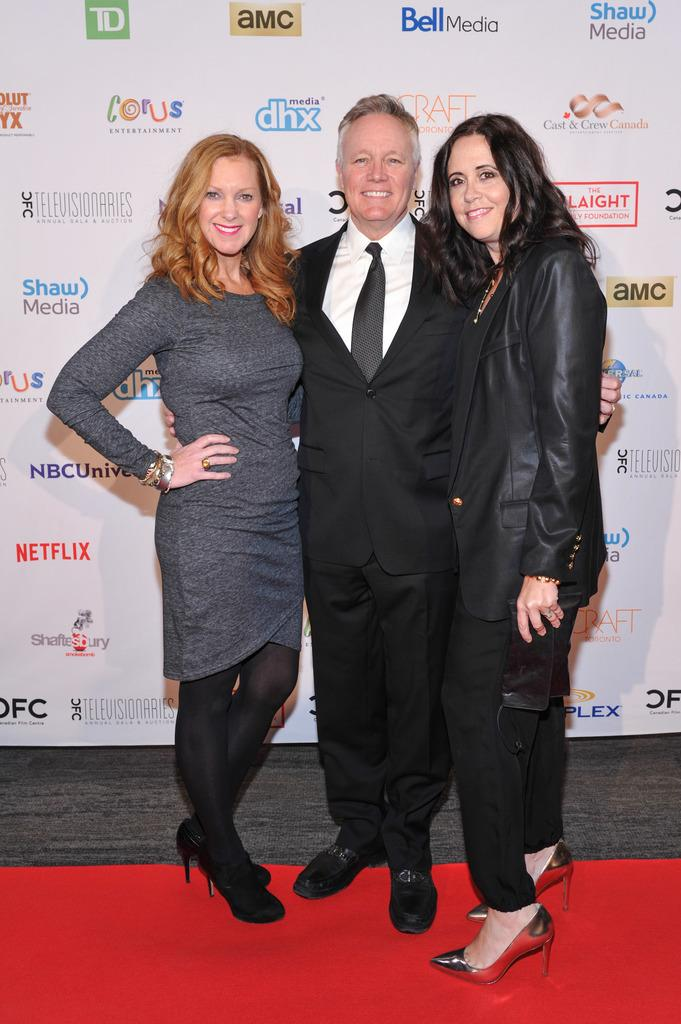How many people are in the image? There are three people standing in the image. What are the people doing in the image? The people are posing for a photo. What is at the bottom of the image? There is a red carpet at the bottom of the image. What can be seen in the background of the image? There is a poster with text in the background of the image. How many mouths can be seen on the clover in the image? There is no clover present in the image, and therefore no mouths can be seen on it. 